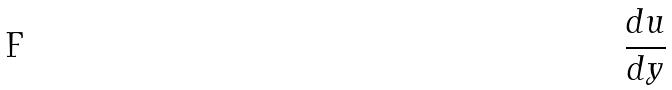<formula> <loc_0><loc_0><loc_500><loc_500>\frac { d u } { d y }</formula> 